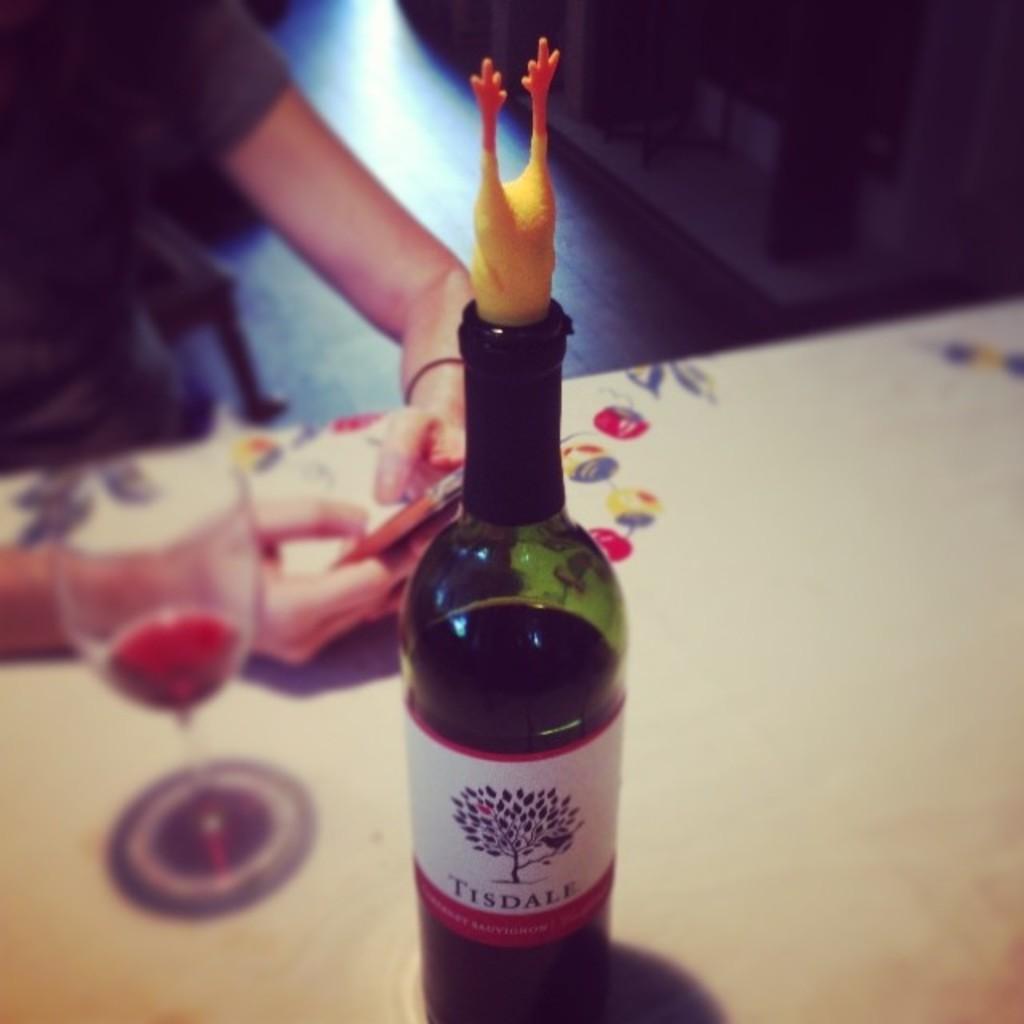Tindale red wine?
Ensure brevity in your answer.  No. 